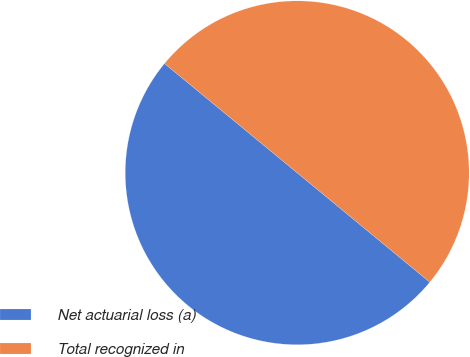<chart> <loc_0><loc_0><loc_500><loc_500><pie_chart><fcel>Net actuarial loss (a)<fcel>Total recognized in<nl><fcel>49.99%<fcel>50.01%<nl></chart> 